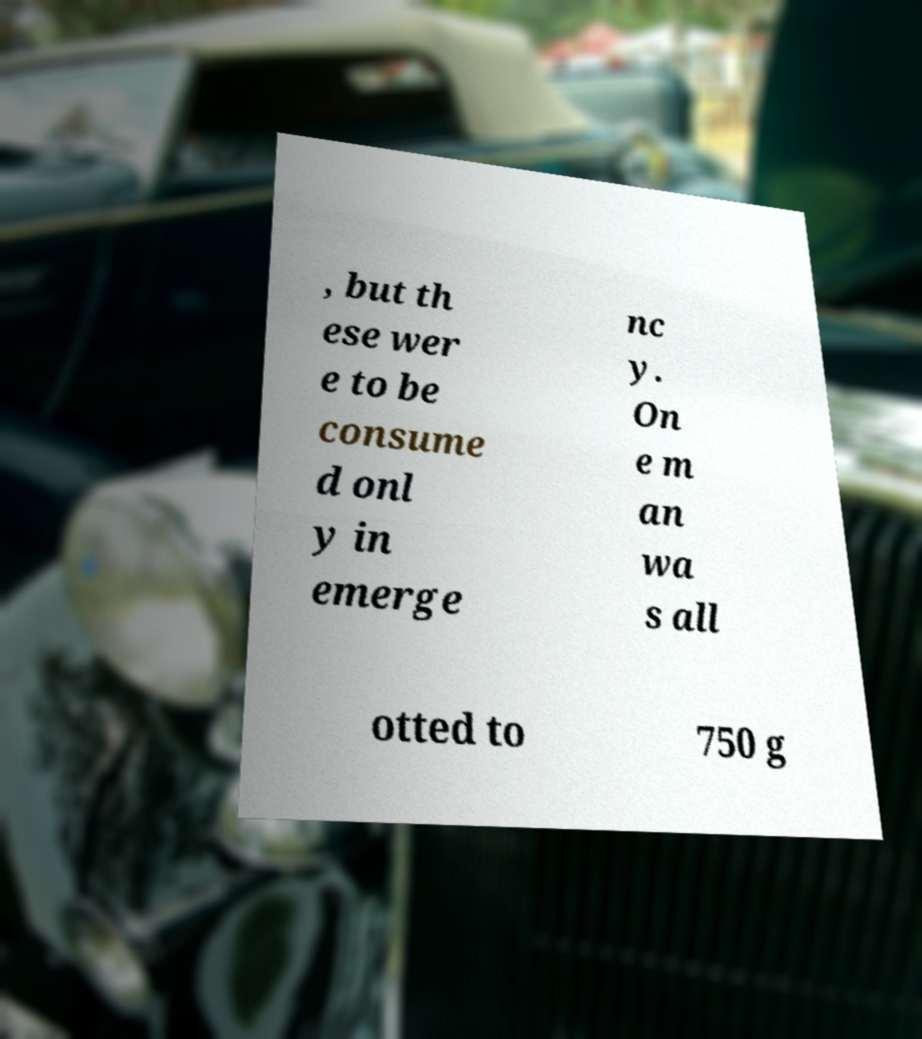Please read and relay the text visible in this image. What does it say? , but th ese wer e to be consume d onl y in emerge nc y. On e m an wa s all otted to 750 g 